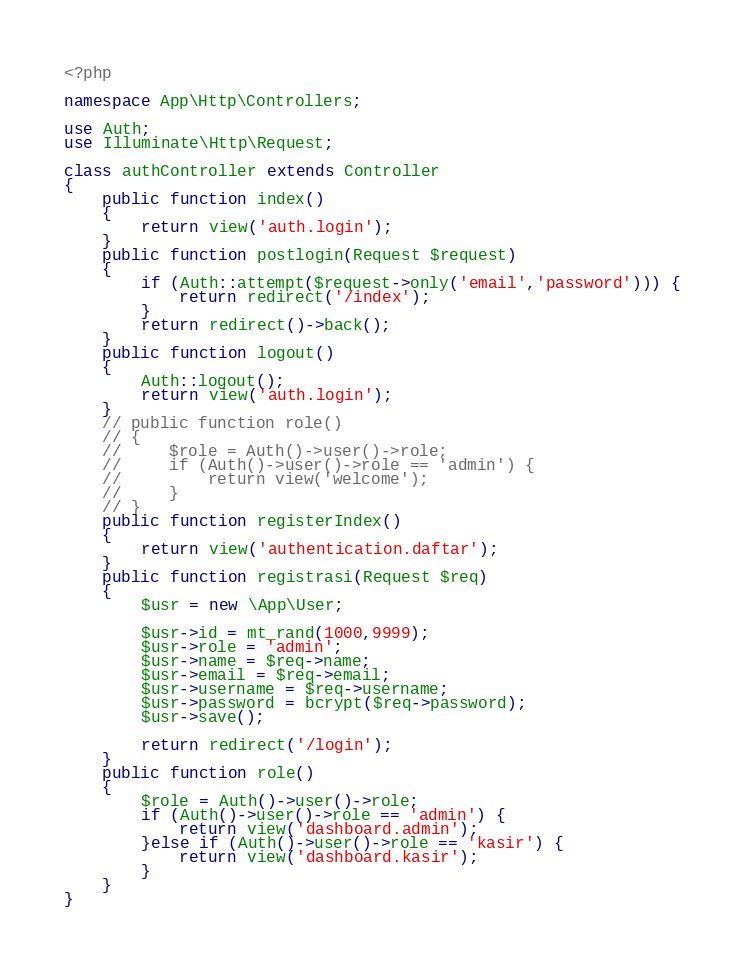<code> <loc_0><loc_0><loc_500><loc_500><_PHP_><?php

namespace App\Http\Controllers;

use Auth;
use Illuminate\Http\Request;

class authController extends Controller
{
    public function index()
    {
    	return view('auth.login');
    }
    public function postlogin(Request $request)
    {
    	if (Auth::attempt($request->only('email','password'))) {
    		return redirect('/index');
    	}
    	return redirect()->back();
    }
    public function logout()
    {
        Auth::logout();
        return view('auth.login');
    }
    // public function role()
    // {
    //     $role = Auth()->user()->role;
    //     if (Auth()->user()->role == 'admin') {
    //         return view('welcome');
    //     }
    // }
    public function registerIndex()
    {
    	return view('authentication.daftar');
    }
    public function registrasi(Request $req)
    {
    	$usr = new \App\User;

    	$usr->id = mt_rand(1000,9999);
    	$usr->role = 'admin';
    	$usr->name = $req->name;
    	$usr->email = $req->email;
    	$usr->username = $req->username;
    	$usr->password = bcrypt($req->password);
    	$usr->save();

    	return redirect('/login');
    }
    public function role()
    {
        $role = Auth()->user()->role;
        if (Auth()->user()->role == 'admin') {
            return view('dashboard.admin');
        }else if (Auth()->user()->role == 'kasir') {
            return view('dashboard.kasir');
        }
    }
}
</code> 